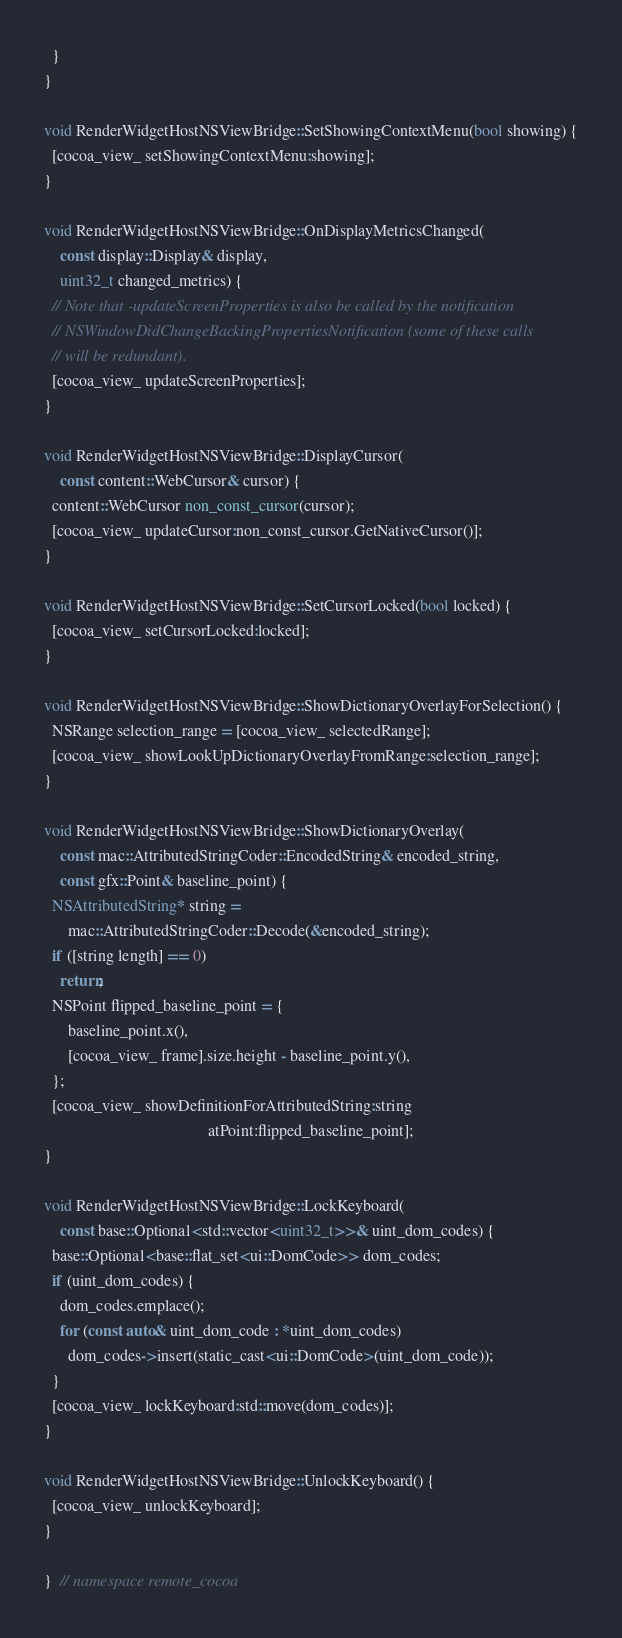Convert code to text. <code><loc_0><loc_0><loc_500><loc_500><_ObjectiveC_>  }
}

void RenderWidgetHostNSViewBridge::SetShowingContextMenu(bool showing) {
  [cocoa_view_ setShowingContextMenu:showing];
}

void RenderWidgetHostNSViewBridge::OnDisplayMetricsChanged(
    const display::Display& display,
    uint32_t changed_metrics) {
  // Note that -updateScreenProperties is also be called by the notification
  // NSWindowDidChangeBackingPropertiesNotification (some of these calls
  // will be redundant).
  [cocoa_view_ updateScreenProperties];
}

void RenderWidgetHostNSViewBridge::DisplayCursor(
    const content::WebCursor& cursor) {
  content::WebCursor non_const_cursor(cursor);
  [cocoa_view_ updateCursor:non_const_cursor.GetNativeCursor()];
}

void RenderWidgetHostNSViewBridge::SetCursorLocked(bool locked) {
  [cocoa_view_ setCursorLocked:locked];
}

void RenderWidgetHostNSViewBridge::ShowDictionaryOverlayForSelection() {
  NSRange selection_range = [cocoa_view_ selectedRange];
  [cocoa_view_ showLookUpDictionaryOverlayFromRange:selection_range];
}

void RenderWidgetHostNSViewBridge::ShowDictionaryOverlay(
    const mac::AttributedStringCoder::EncodedString& encoded_string,
    const gfx::Point& baseline_point) {
  NSAttributedString* string =
      mac::AttributedStringCoder::Decode(&encoded_string);
  if ([string length] == 0)
    return;
  NSPoint flipped_baseline_point = {
      baseline_point.x(),
      [cocoa_view_ frame].size.height - baseline_point.y(),
  };
  [cocoa_view_ showDefinitionForAttributedString:string
                                         atPoint:flipped_baseline_point];
}

void RenderWidgetHostNSViewBridge::LockKeyboard(
    const base::Optional<std::vector<uint32_t>>& uint_dom_codes) {
  base::Optional<base::flat_set<ui::DomCode>> dom_codes;
  if (uint_dom_codes) {
    dom_codes.emplace();
    for (const auto& uint_dom_code : *uint_dom_codes)
      dom_codes->insert(static_cast<ui::DomCode>(uint_dom_code));
  }
  [cocoa_view_ lockKeyboard:std::move(dom_codes)];
}

void RenderWidgetHostNSViewBridge::UnlockKeyboard() {
  [cocoa_view_ unlockKeyboard];
}

}  // namespace remote_cocoa
</code> 